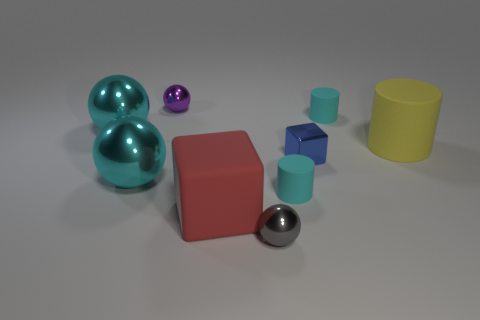Subtract all yellow blocks. How many cyan balls are left? 2 Subtract all cyan rubber cylinders. How many cylinders are left? 1 Add 1 tiny blue blocks. How many objects exist? 10 Subtract all gray balls. How many balls are left? 3 Subtract all cylinders. How many objects are left? 6 Subtract all red balls. Subtract all green cubes. How many balls are left? 4 Add 6 large yellow matte spheres. How many large yellow matte spheres exist? 6 Subtract 0 yellow balls. How many objects are left? 9 Subtract all yellow cylinders. Subtract all green matte cylinders. How many objects are left? 8 Add 5 large cyan things. How many large cyan things are left? 7 